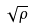Convert formula to latex. <formula><loc_0><loc_0><loc_500><loc_500>\sqrt { \rho }</formula> 